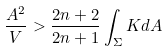Convert formula to latex. <formula><loc_0><loc_0><loc_500><loc_500>\frac { A ^ { 2 } } { V } > \frac { 2 n + 2 } { 2 n + 1 } \int _ { \Sigma } K d A</formula> 